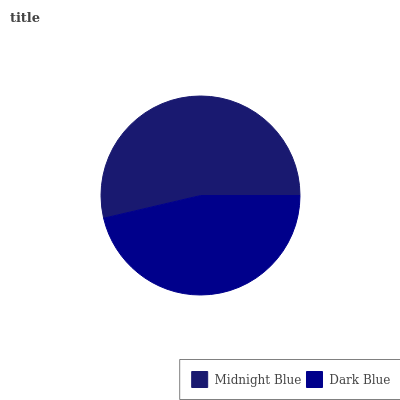Is Dark Blue the minimum?
Answer yes or no. Yes. Is Midnight Blue the maximum?
Answer yes or no. Yes. Is Dark Blue the maximum?
Answer yes or no. No. Is Midnight Blue greater than Dark Blue?
Answer yes or no. Yes. Is Dark Blue less than Midnight Blue?
Answer yes or no. Yes. Is Dark Blue greater than Midnight Blue?
Answer yes or no. No. Is Midnight Blue less than Dark Blue?
Answer yes or no. No. Is Midnight Blue the high median?
Answer yes or no. Yes. Is Dark Blue the low median?
Answer yes or no. Yes. Is Dark Blue the high median?
Answer yes or no. No. Is Midnight Blue the low median?
Answer yes or no. No. 